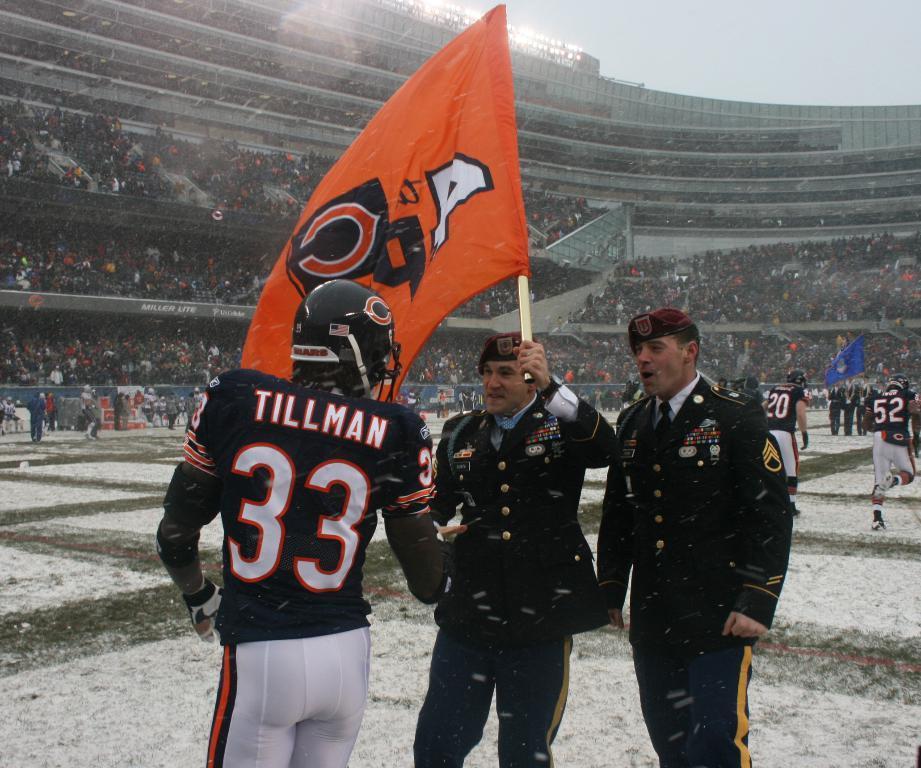In one or two sentences, can you explain what this image depicts? This picture describes about group of people, few people wore helmets, in the middle of the image we can see a man, he is holding a flag, in the background we can find group of people in the stadium. 